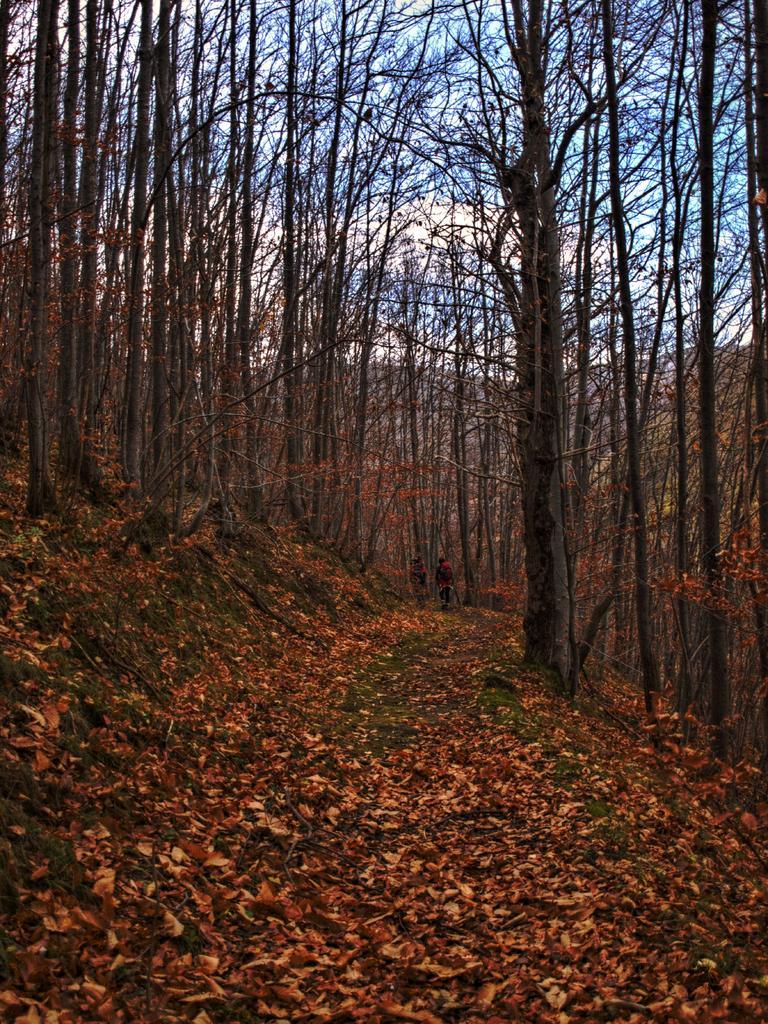Can you describe this image briefly? In this image, I can see the trees with branches and leaves. I think this is a hill. I can see the dried leaves lying on the ground. 